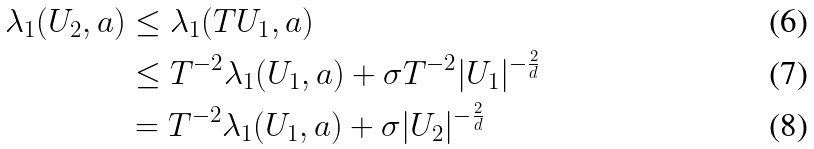Convert formula to latex. <formula><loc_0><loc_0><loc_500><loc_500>\lambda _ { 1 } ( U _ { 2 } , a ) & \leq \lambda _ { 1 } ( T U _ { 1 } , a ) \\ & \leq T ^ { - 2 } \lambda _ { 1 } ( U _ { 1 } , a ) + \sigma T ^ { - 2 } | U _ { 1 } | ^ { - \frac { 2 } { d } } \\ & = T ^ { - 2 } \lambda _ { 1 } ( U _ { 1 } , a ) + \sigma | U _ { 2 } | ^ { - \frac { 2 } { d } }</formula> 